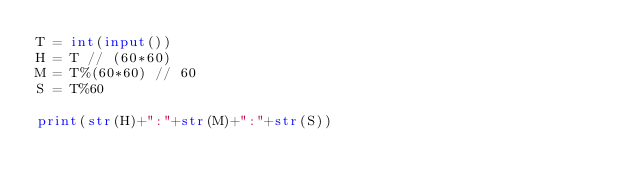Convert code to text. <code><loc_0><loc_0><loc_500><loc_500><_Python_>T = int(input()) 
H = T // (60*60)
M = T%(60*60) // 60
S = T%60

print(str(H)+":"+str(M)+":"+str(S))
</code> 